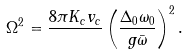Convert formula to latex. <formula><loc_0><loc_0><loc_500><loc_500>\Omega ^ { 2 } = \frac { 8 \pi K _ { c } v _ { c } } { } \left ( \frac { \Delta _ { 0 } \omega _ { 0 } } { g \bar { \omega } } \right ) ^ { 2 } .</formula> 